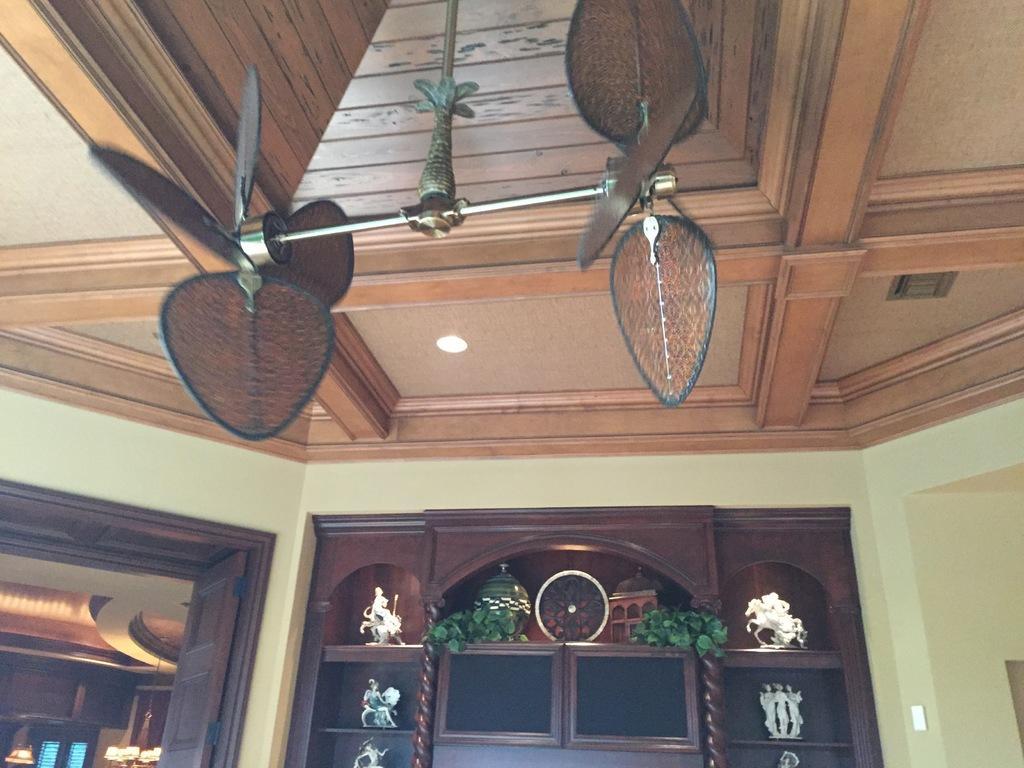In one or two sentences, can you explain what this image depicts? In this image I can see few sculptures and few plants on these shelves. I can also see few brown colour things over here. 